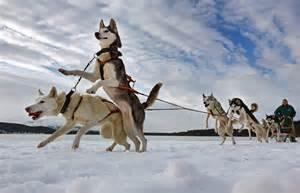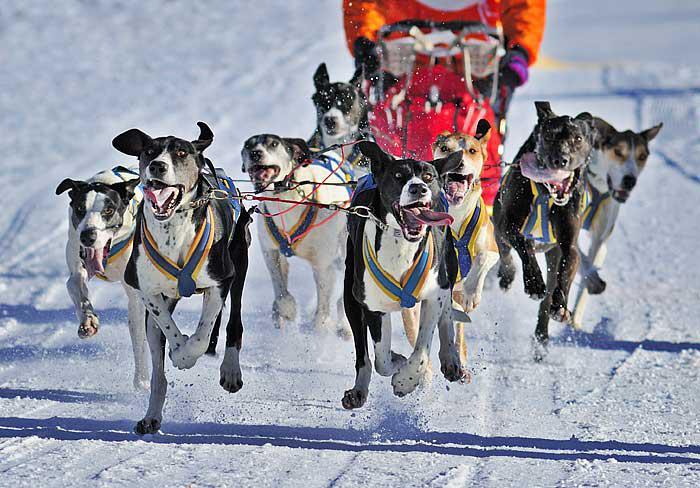The first image is the image on the left, the second image is the image on the right. For the images shown, is this caption "Each image shows a man in a numbered vest being pulled by a team of dogs moving forward." true? Answer yes or no. No. 